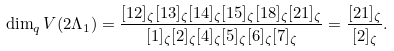<formula> <loc_0><loc_0><loc_500><loc_500>\dim _ { q } V ( 2 \Lambda _ { 1 } ) = \frac { [ 1 2 ] _ { \zeta } [ 1 3 ] _ { \zeta } [ 1 4 ] _ { \zeta } [ 1 5 ] _ { \zeta } [ 1 8 ] _ { \zeta } [ 2 1 ] _ { \zeta } } { [ 1 ] _ { \zeta } [ 2 ] _ { \zeta } [ 4 ] _ { \zeta } [ 5 ] _ { \zeta } [ 6 ] _ { \zeta } [ 7 ] _ { \zeta } } = \frac { [ 2 1 ] _ { \zeta } } { [ 2 ] _ { \zeta } } .</formula> 